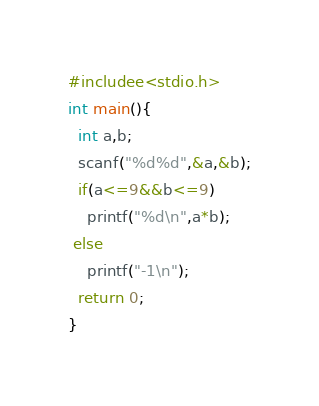<code> <loc_0><loc_0><loc_500><loc_500><_C_>#includee<stdio.h>
int main(){
  int a,b;
  scanf("%d%d",&a,&b);
  if(a<=9&&b<=9)
    printf("%d\n",a*b);
 else
    printf("-1\n");
  return 0;
}
</code> 